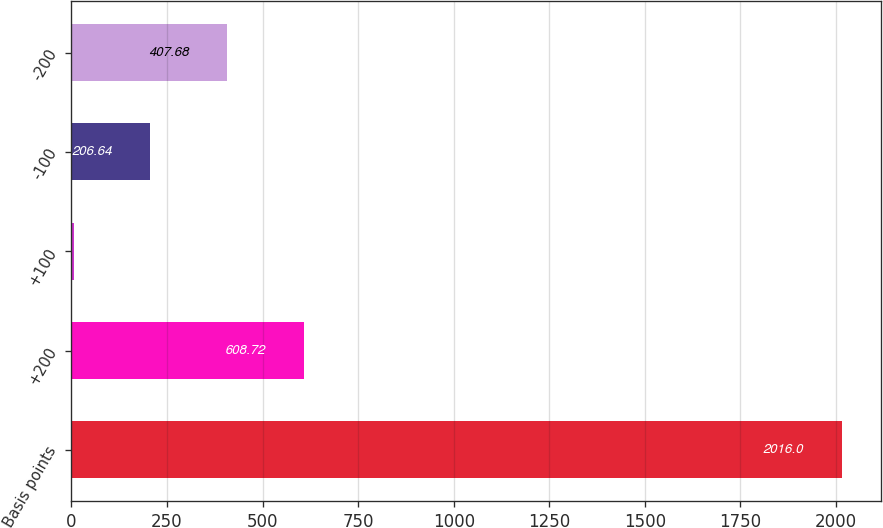<chart> <loc_0><loc_0><loc_500><loc_500><bar_chart><fcel>Basis points<fcel>+200<fcel>+100<fcel>-100<fcel>-200<nl><fcel>2016<fcel>608.72<fcel>5.6<fcel>206.64<fcel>407.68<nl></chart> 